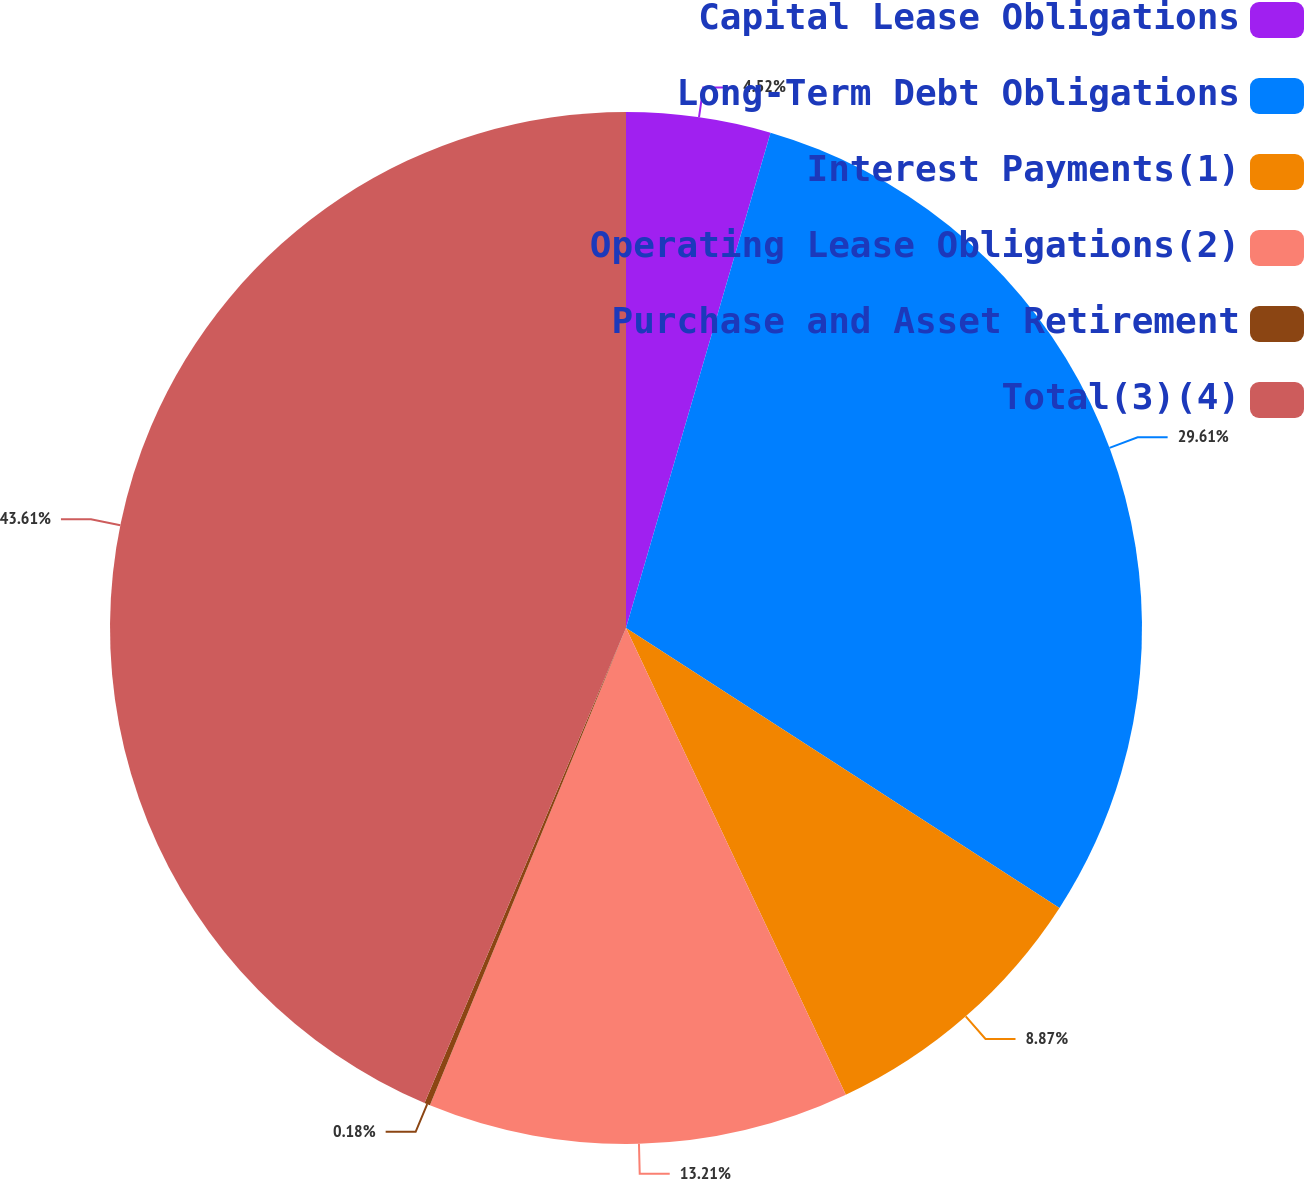Convert chart. <chart><loc_0><loc_0><loc_500><loc_500><pie_chart><fcel>Capital Lease Obligations<fcel>Long-Term Debt Obligations<fcel>Interest Payments(1)<fcel>Operating Lease Obligations(2)<fcel>Purchase and Asset Retirement<fcel>Total(3)(4)<nl><fcel>4.52%<fcel>29.61%<fcel>8.87%<fcel>13.21%<fcel>0.18%<fcel>43.62%<nl></chart> 